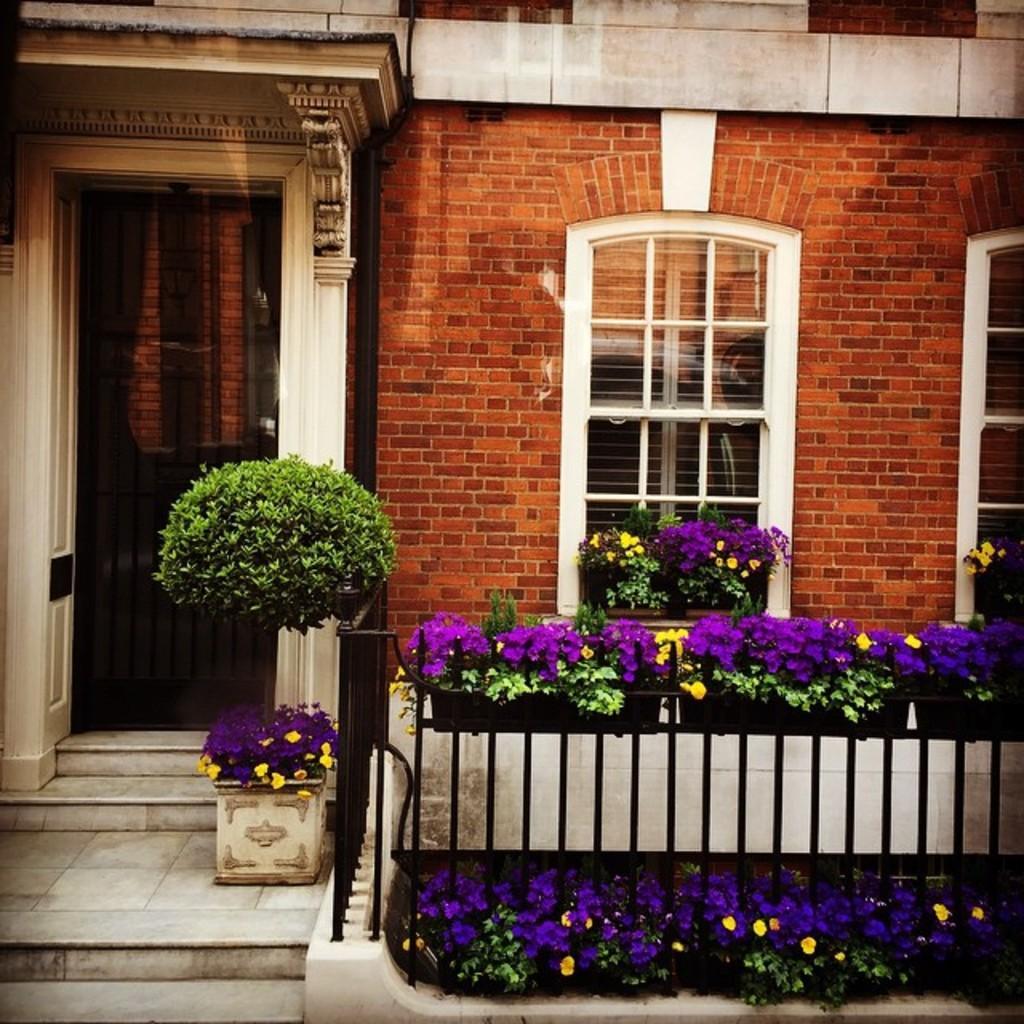In one or two sentences, can you explain what this image depicts? In this image we can see a building with windows and the railing. We can also see some plants with flowers. 